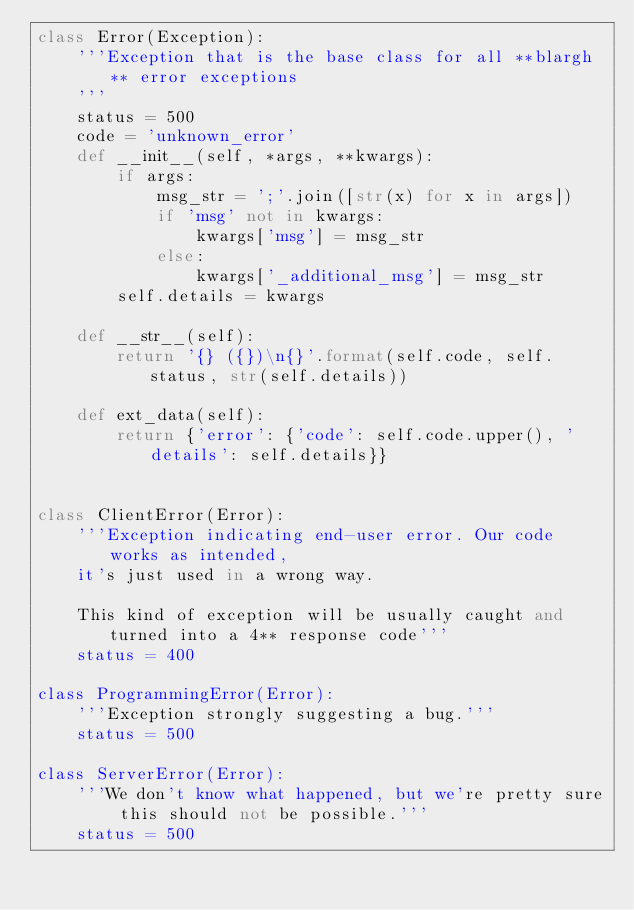Convert code to text. <code><loc_0><loc_0><loc_500><loc_500><_Python_>class Error(Exception):
    '''Exception that is the base class for all **blargh** error exceptions
    '''
    status = 500
    code = 'unknown_error'
    def __init__(self, *args, **kwargs):
        if args:
            msg_str = ';'.join([str(x) for x in args])
            if 'msg' not in kwargs:
                kwargs['msg'] = msg_str
            else:
                kwargs['_additional_msg'] = msg_str
        self.details = kwargs

    def __str__(self):
        return '{} ({})\n{}'.format(self.code, self.status, str(self.details))

    def ext_data(self):
        return {'error': {'code': self.code.upper(), 'details': self.details}}


class ClientError(Error):
    '''Exception indicating end-user error. Our code works as intended, 
    it's just used in a wrong way.

    This kind of exception will be usually caught and turned into a 4** response code'''
    status = 400

class ProgrammingError(Error):
    '''Exception strongly suggesting a bug.'''
    status = 500

class ServerError(Error):
    '''We don't know what happened, but we're pretty sure this should not be possible.'''
    status = 500
</code> 